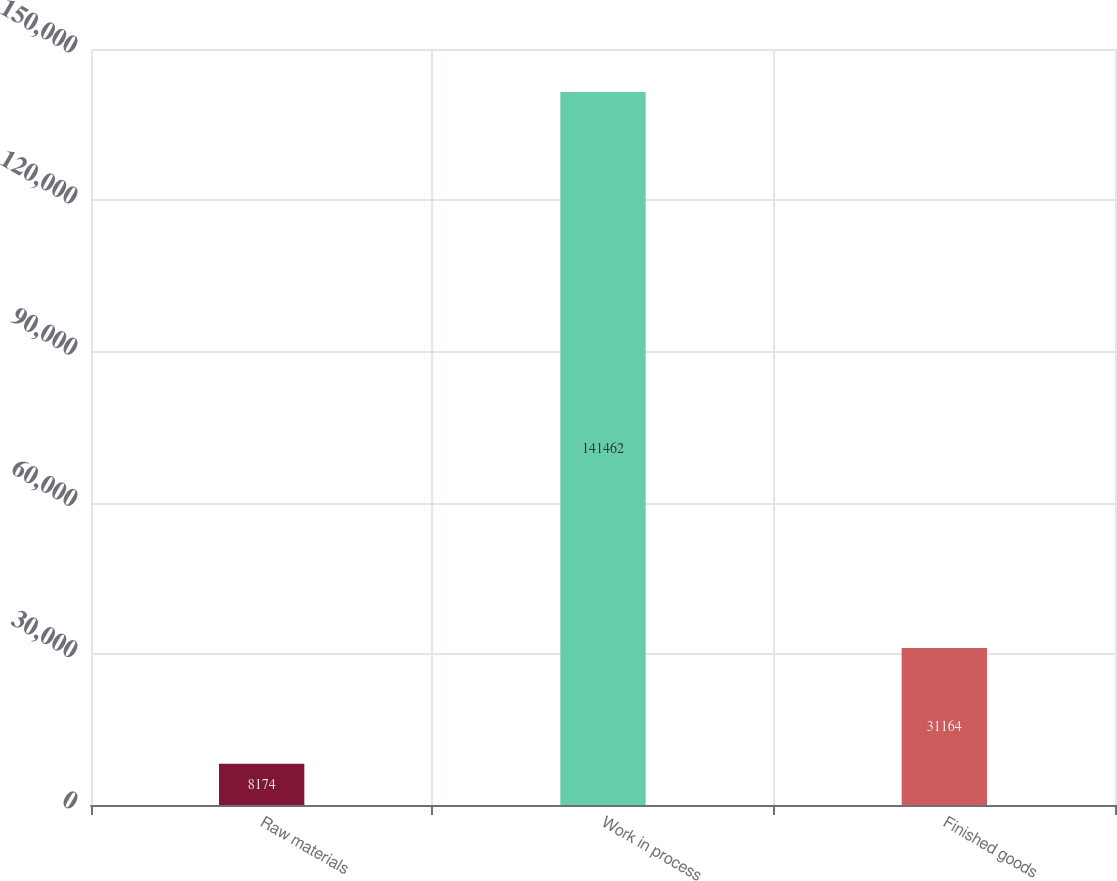Convert chart to OTSL. <chart><loc_0><loc_0><loc_500><loc_500><bar_chart><fcel>Raw materials<fcel>Work in process<fcel>Finished goods<nl><fcel>8174<fcel>141462<fcel>31164<nl></chart> 